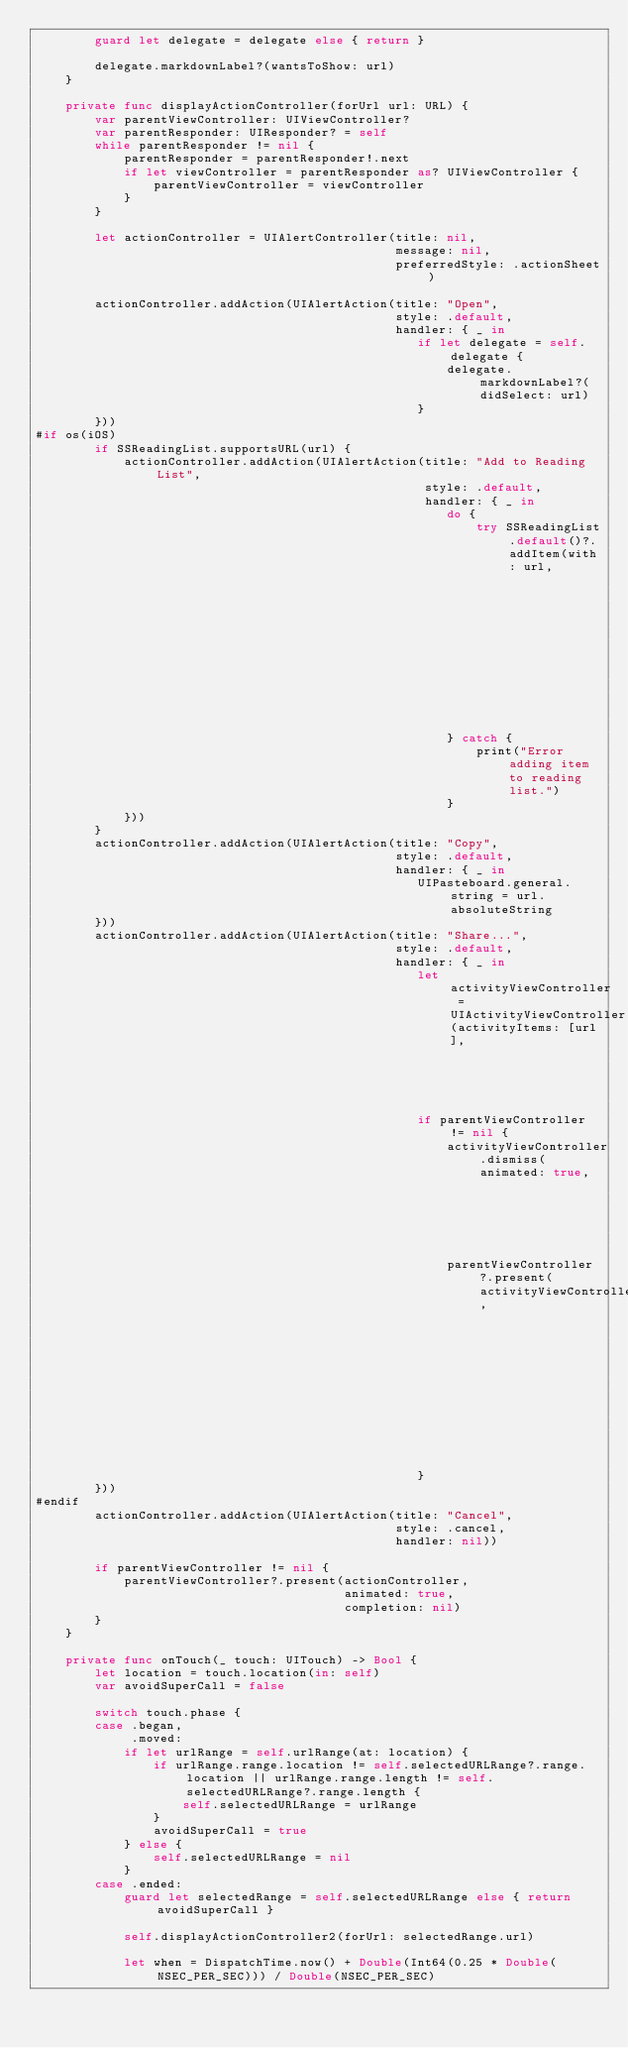Convert code to text. <code><loc_0><loc_0><loc_500><loc_500><_Swift_>        guard let delegate = delegate else { return }

        delegate.markdownLabel?(wantsToShow: url)
    }
    
    private func displayActionController(forUrl url: URL) {
        var parentViewController: UIViewController?
        var parentResponder: UIResponder? = self
        while parentResponder != nil {
            parentResponder = parentResponder!.next
            if let viewController = parentResponder as? UIViewController {
                parentViewController = viewController
            }
        }

        let actionController = UIAlertController(title: nil,
                                                 message: nil,
                                                 preferredStyle: .actionSheet)

        actionController.addAction(UIAlertAction(title: "Open",
                                                 style: .default,
                                                 handler: { _ in
                                                    if let delegate = self.delegate {
                                                        delegate.markdownLabel?(didSelect: url)
                                                    }
        }))
#if os(iOS)
        if SSReadingList.supportsURL(url) {
            actionController.addAction(UIAlertAction(title: "Add to Reading List",
                                                     style: .default,
                                                     handler: { _ in
                                                        do {
                                                            try SSReadingList.default()?.addItem(with: url,
                                                                                                 title: nil,
                                                                                                 previewText: nil)
                                                        } catch {
                                                            print("Error adding item to reading list.")
                                                        }
            }))
        }
        actionController.addAction(UIAlertAction(title: "Copy",
                                                 style: .default,
                                                 handler: { _ in
                                                    UIPasteboard.general.string = url.absoluteString
        }))
        actionController.addAction(UIAlertAction(title: "Share...",
                                                 style: .default,
                                                 handler: { _ in
                                                    let activityViewController = UIActivityViewController(activityItems: [url],
                                                                                                          applicationActivities: [])
                                                    if parentViewController != nil {
                                                        activityViewController.dismiss(animated: true,
                                                                                       completion: nil)
                                                        parentViewController?.present(activityViewController,
                                                                                      animated: true,
                                                                                      completion: nil)
                                                    }
        }))
#endif
        actionController.addAction(UIAlertAction(title: "Cancel",
                                                 style: .cancel,
                                                 handler: nil))

        if parentViewController != nil {
            parentViewController?.present(actionController,
                                          animated: true,
                                          completion: nil)
        }
    }

    private func onTouch(_ touch: UITouch) -> Bool {
        let location = touch.location(in: self)
        var avoidSuperCall = false

        switch touch.phase {
        case .began,
             .moved:
            if let urlRange = self.urlRange(at: location) {
                if urlRange.range.location != self.selectedURLRange?.range.location || urlRange.range.length != self.selectedURLRange?.range.length {
                    self.selectedURLRange = urlRange
                }
                avoidSuperCall = true
            } else {
                self.selectedURLRange = nil
            }
        case .ended:
            guard let selectedRange = self.selectedURLRange else { return avoidSuperCall }

            self.displayActionController2(forUrl: selectedRange.url)

            let when = DispatchTime.now() + Double(Int64(0.25 * Double(NSEC_PER_SEC))) / Double(NSEC_PER_SEC)</code> 